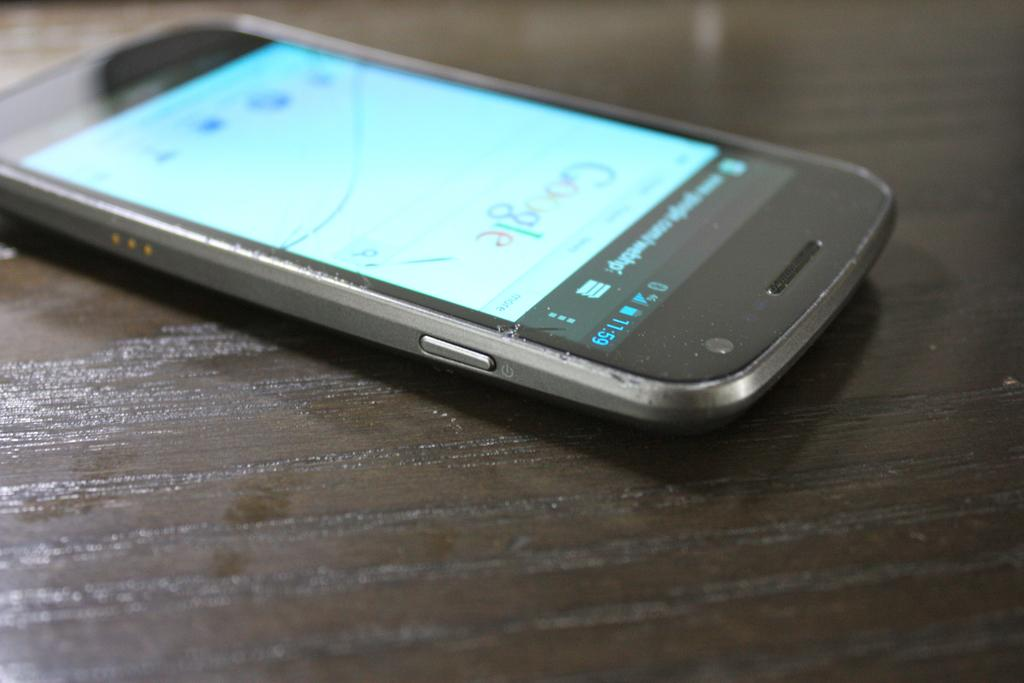Provide a one-sentence caption for the provided image. A cell phone with a google search application open lying on a desk. 